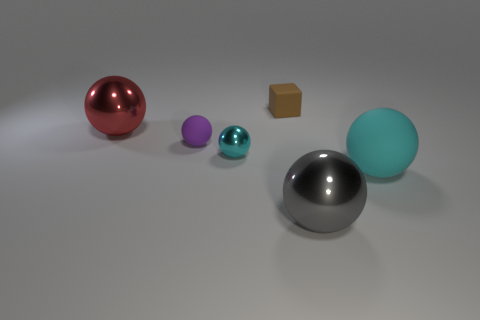Subtract 2 spheres. How many spheres are left? 3 Subtract all cyan spheres. How many spheres are left? 3 Subtract all big red spheres. How many spheres are left? 4 Subtract all purple balls. Subtract all red cylinders. How many balls are left? 4 Add 4 large rubber things. How many objects exist? 10 Subtract all cubes. How many objects are left? 5 Subtract all small green matte cubes. Subtract all balls. How many objects are left? 1 Add 3 red objects. How many red objects are left? 4 Add 4 small matte blocks. How many small matte blocks exist? 5 Subtract 0 cyan blocks. How many objects are left? 6 